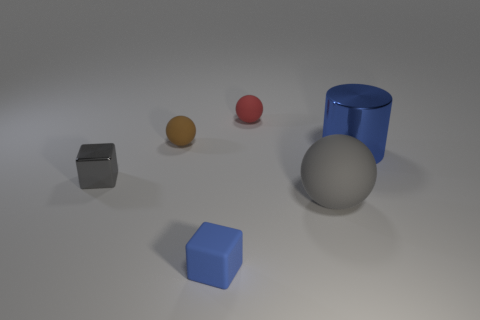Do the metal cube and the blue cylinder have the same size?
Your response must be concise. No. What number of cylinders are either blue rubber things or small brown objects?
Provide a succinct answer. 0. There is a cube in front of the gray rubber thing; what number of spheres are to the right of it?
Give a very brief answer. 2. Do the tiny gray metal object and the tiny blue rubber object have the same shape?
Your answer should be compact. Yes. What is the size of the red matte object that is the same shape as the small brown rubber object?
Give a very brief answer. Small. What is the shape of the metal thing that is left of the ball in front of the metal cylinder?
Your answer should be compact. Cube. What size is the gray cube?
Ensure brevity in your answer.  Small. There is a small blue rubber thing; what shape is it?
Make the answer very short. Cube. There is a blue rubber object; does it have the same shape as the metal thing that is in front of the big metallic thing?
Provide a succinct answer. Yes. There is a metal thing left of the tiny blue matte object; is it the same shape as the tiny blue matte object?
Offer a terse response. Yes. 